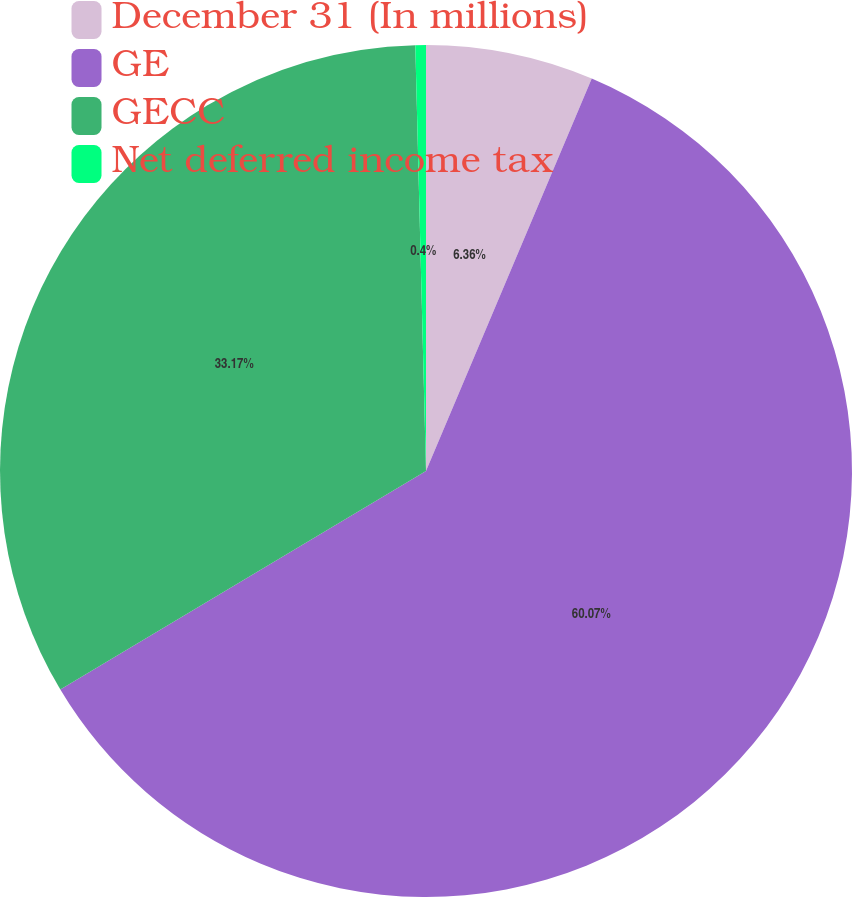Convert chart to OTSL. <chart><loc_0><loc_0><loc_500><loc_500><pie_chart><fcel>December 31 (In millions)<fcel>GE<fcel>GECC<fcel>Net deferred income tax<nl><fcel>6.36%<fcel>60.06%<fcel>33.17%<fcel>0.4%<nl></chart> 